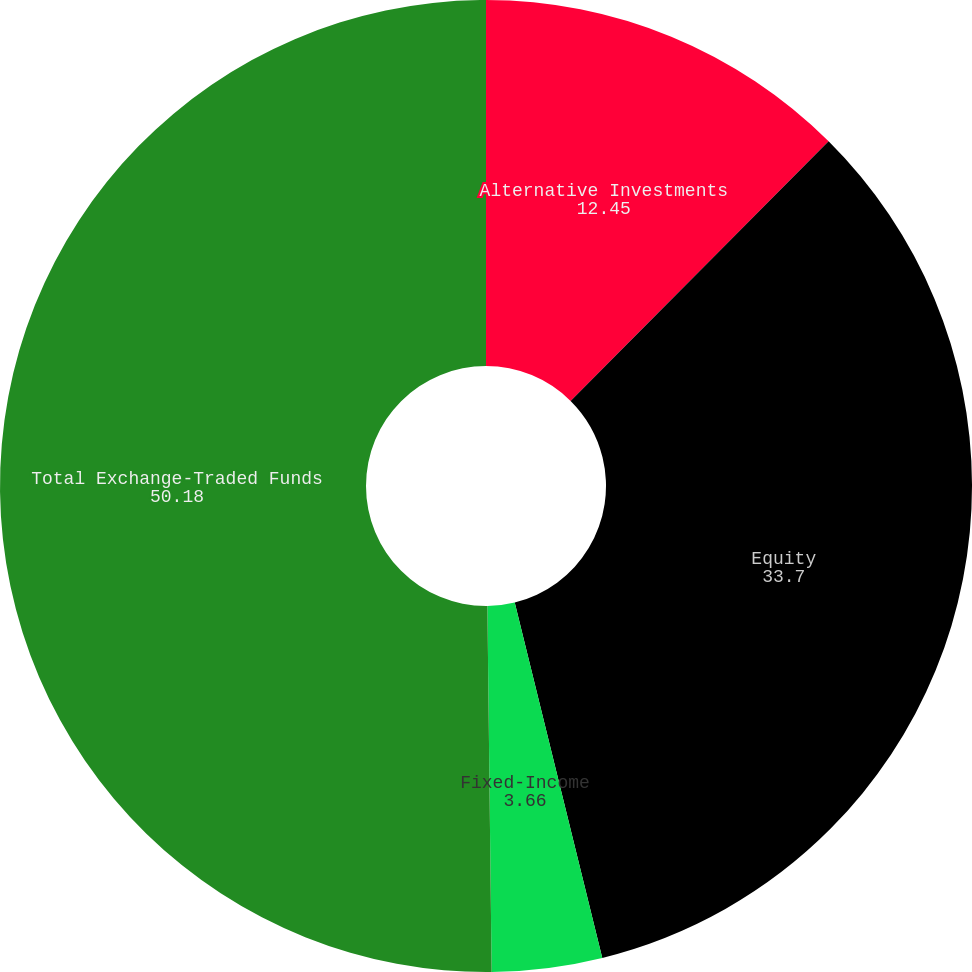Convert chart. <chart><loc_0><loc_0><loc_500><loc_500><pie_chart><fcel>Alternative Investments<fcel>Equity<fcel>Fixed-Income<fcel>Total Exchange-Traded Funds<nl><fcel>12.45%<fcel>33.7%<fcel>3.66%<fcel>50.18%<nl></chart> 